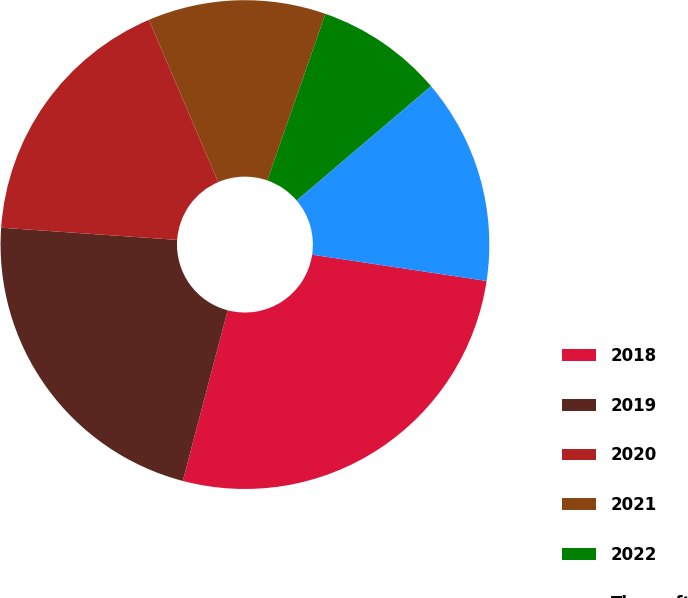Convert chart to OTSL. <chart><loc_0><loc_0><loc_500><loc_500><pie_chart><fcel>2018<fcel>2019<fcel>2020<fcel>2021<fcel>2022<fcel>Thereafter<nl><fcel>26.72%<fcel>22.01%<fcel>17.47%<fcel>11.77%<fcel>8.44%<fcel>13.6%<nl></chart> 